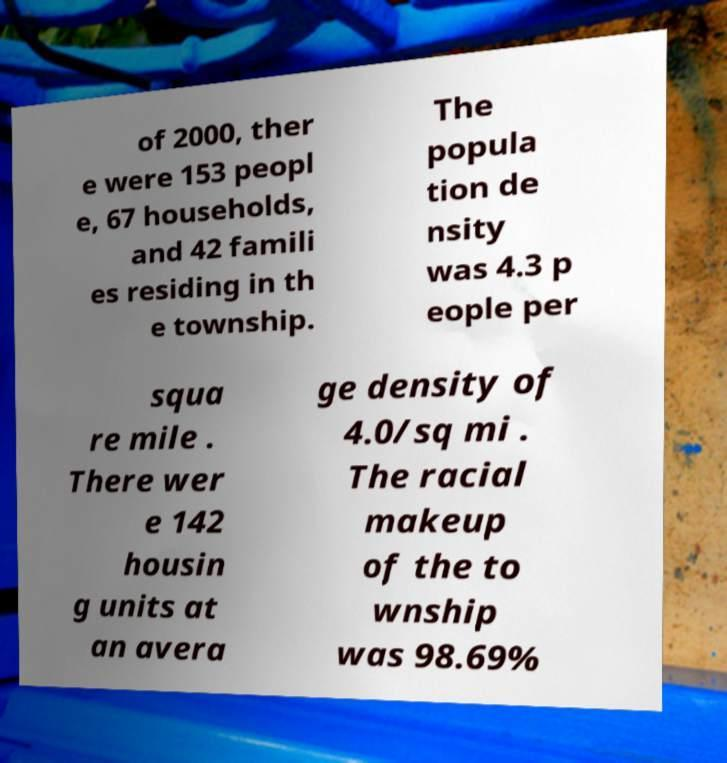Can you accurately transcribe the text from the provided image for me? of 2000, ther e were 153 peopl e, 67 households, and 42 famili es residing in th e township. The popula tion de nsity was 4.3 p eople per squa re mile . There wer e 142 housin g units at an avera ge density of 4.0/sq mi . The racial makeup of the to wnship was 98.69% 